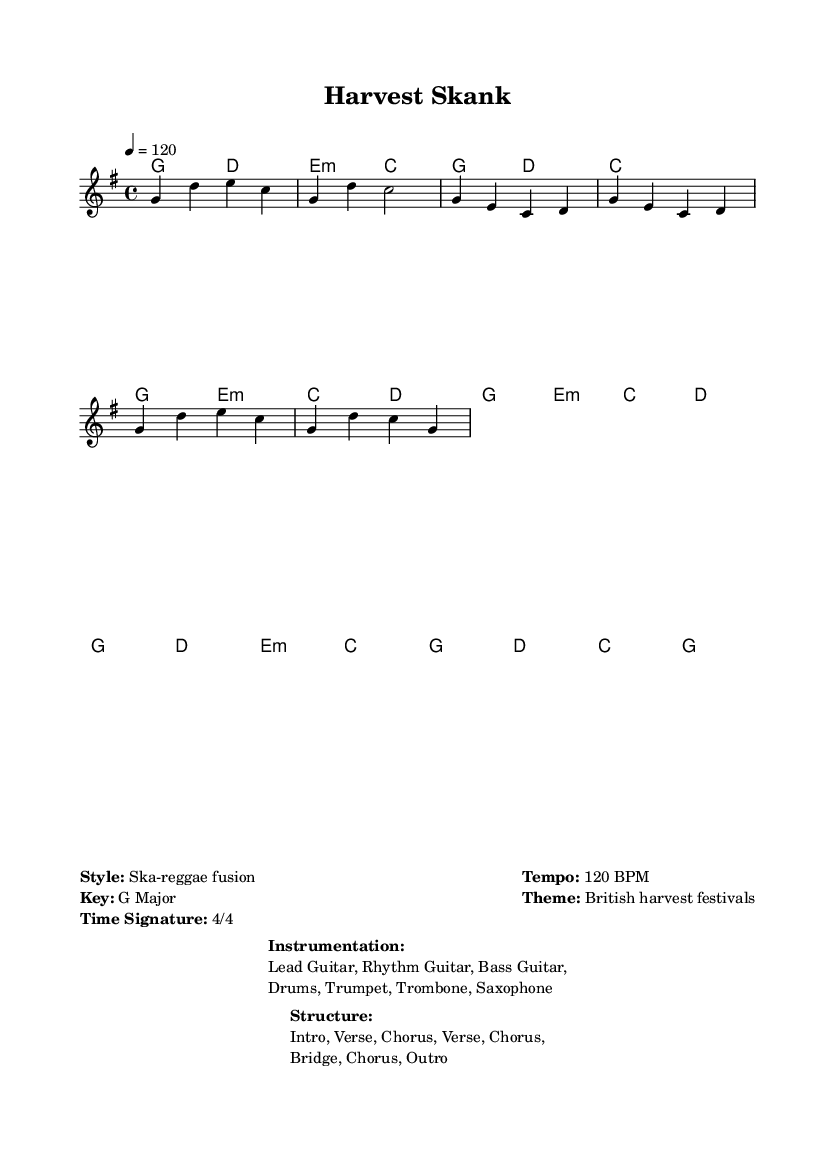What is the key signature of this music? The key signature is G major, indicated by one sharp (F#). This is commonly represented in the header section of sheet music.
Answer: G major What is the time signature of this music? The time signature is 4/4, which means there are four beats in each measure and the quarter note gets one beat. This can be seen at the beginning of the piece in the global section.
Answer: 4/4 What is the tempo marking for this piece? The tempo is marked at 120 BPM, which indicates the speed at which the music should be played. This tempo is typically found in the global section as well.
Answer: 120 BPM How many verses are in the structure of this music? The structure includes two verses as explicitly stated in the layout of the song sections (Intro, Verse, Chorus, Verse, Chorus, Bridge, Chorus, Outro).
Answer: 2 What is the primary theme represented in this music? The theme is "British harvest festivals," which embodies the celebration of traditional agricultural harvests in Britain. This theme is indicated in the markup section of the sheet music.
Answer: British harvest festivals What instruments are used in this music? The instruments listed are Lead Guitar, Rhythm Guitar, Bass Guitar, Drums, Trumpet, Trombone, and Saxophone, providing a full ska-reggae sound. This information appears in the instrumentation markup section.
Answer: Lead Guitar, Rhythm Guitar, Bass Guitar, Drums, Trumpet, Trombone, Saxophone Which section follows the second verse in this structure? The section that follows the second verse is indicated to be a chorus, as seen in the layout outline of the music. This shows the flow of the composition.
Answer: Chorus 